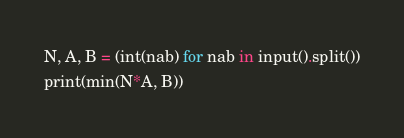Convert code to text. <code><loc_0><loc_0><loc_500><loc_500><_Python_>N, A, B = (int(nab) for nab in input().split())
print(min(N*A, B))</code> 